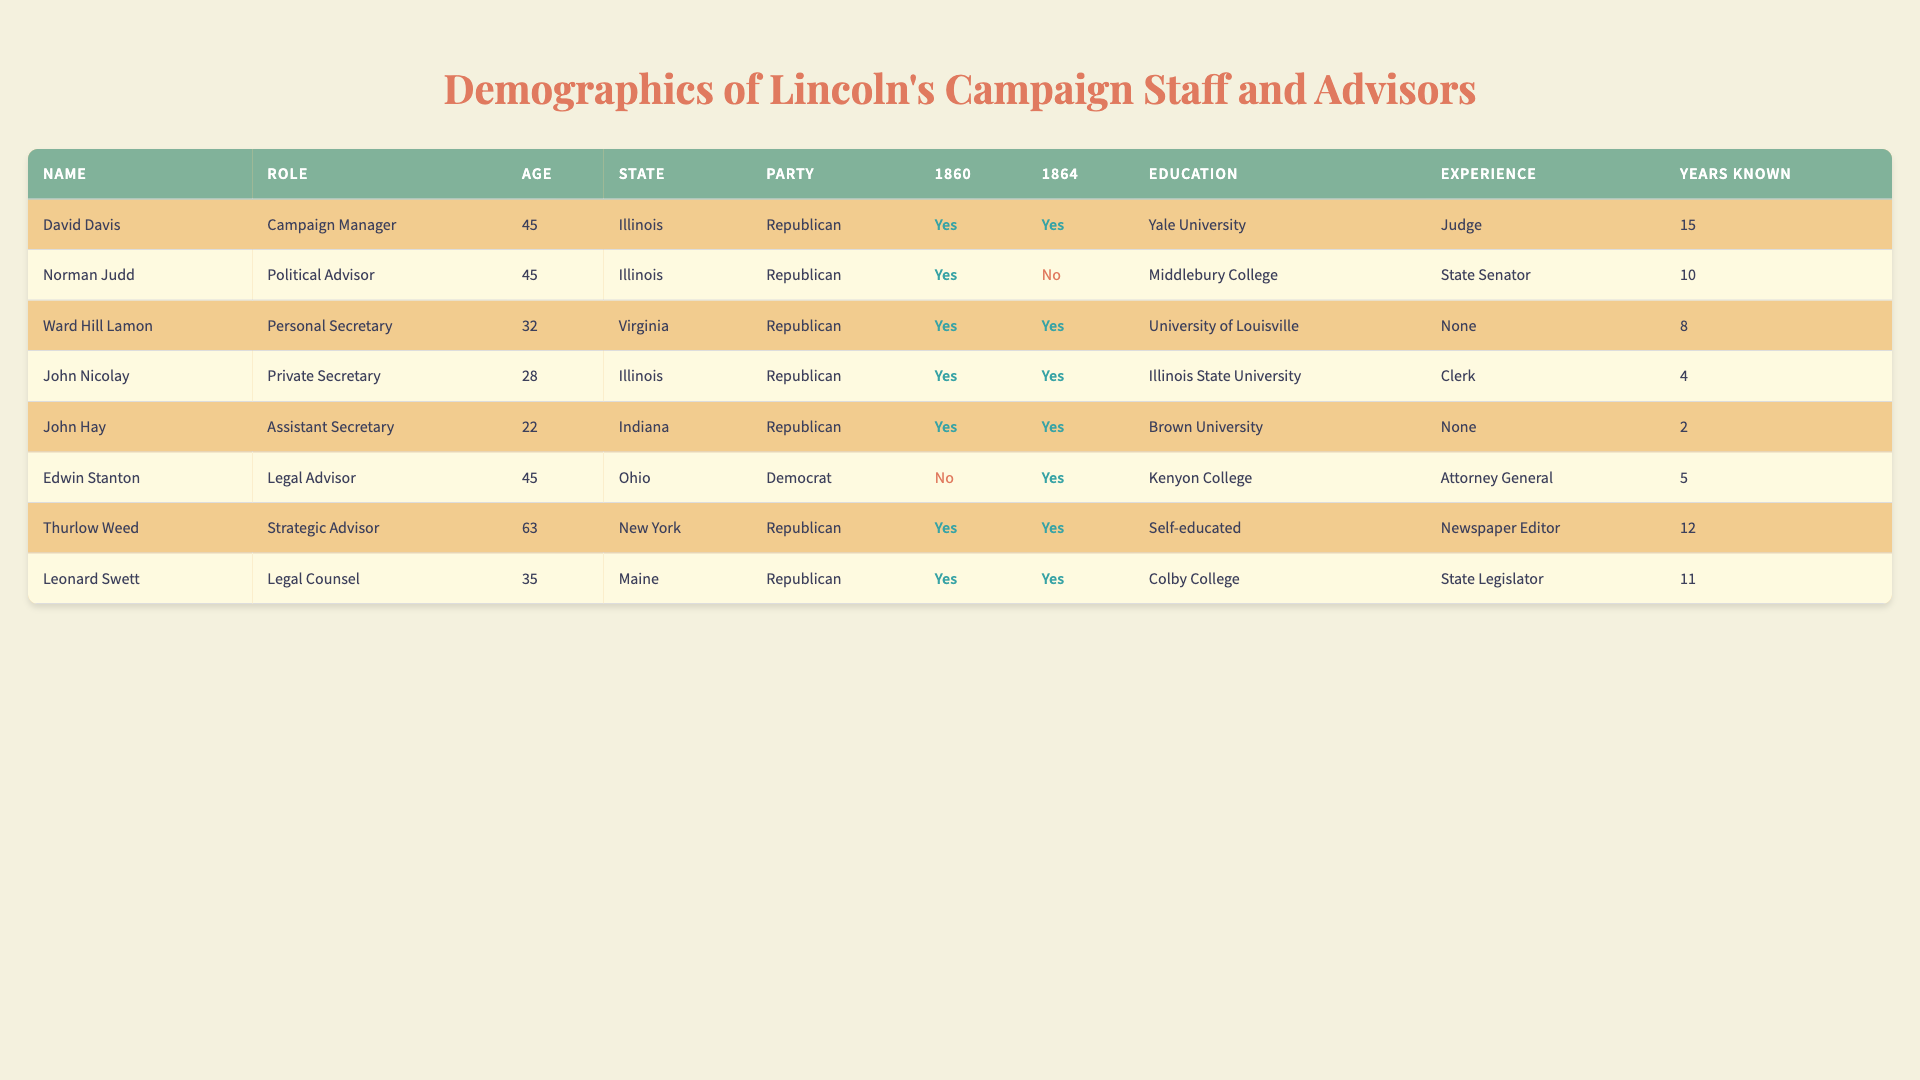What is the role of David Davis? David Davis is listed in the table under the "Role" column as the "Campaign Manager."
Answer: Campaign Manager How many staff members participated in the 1860 campaign? By counting the entries in the table where "1860" is marked as "Yes," we find that there are 6 staff members who participated in the 1860 campaign.
Answer: 6 Which state did Norman Judd represent? The table shows Norman Judd's state in the "State" column as "Illinois."
Answer: Illinois Did Edwin Stanton participate in the 1860 campaign? Looking at the "1860" column for Edwin Stanton, it shows "No," indicating that he did not participate in that campaign.
Answer: No What is the average age of the campaign staff members? The ages of the staff members are: 45, 45, 32, 28, 22, 45, 63, and 35. Summing these ages gives 315, which divided by 8 (the number of members) results in 39.375, rounded down is 39.
Answer: 39 Which staff member has the most political experience? The "Previous Political Experience" column indicates that the "Legal Advisor" Edwin Stanton had previous experience as Attorney General, which is a significant role compared to others.
Answer: Edwin Stanton How many staff members had previous political experience listed as "None"? By examining the "Previous Political Experience" column, we see two staff members noted having "None."
Answer: 2 What is the total number of years that John Hay has known Lincoln? John's years known Lincoln, as shown in the "Years Known" column, is 2.
Answer: 2 Is it true that all Republican staff members participated in the 1864 campaign? Looking through the "1864" column, Norman Judd (Republican) shows "No," meaning not all Republican staff members participated in that campaign.
Answer: No Which staff member has the longest known association with Lincoln? Reviewing the "Years Known" column, David Davis shows the highest value of 15 years of known association with Lincoln.
Answer: David Davis What is the party affiliation of the oldest campaign staff member? The oldest staff member in the table is Thurlow Weed, aged 63, with a party affiliation of "Republican."
Answer: Republican 